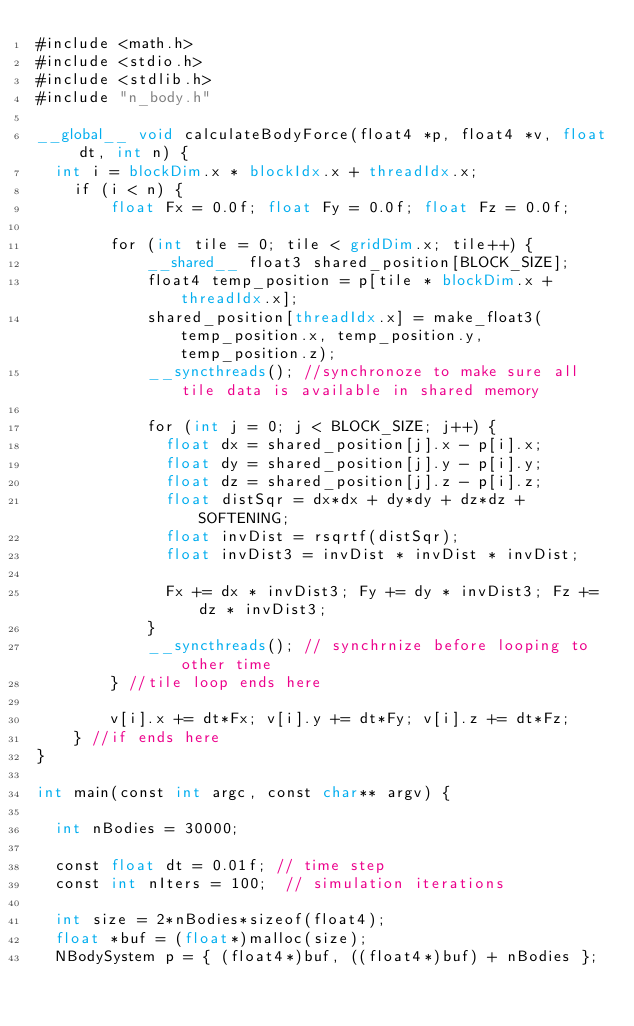Convert code to text. <code><loc_0><loc_0><loc_500><loc_500><_Cuda_>#include <math.h>
#include <stdio.h>
#include <stdlib.h>
#include "n_body.h"

__global__ void calculateBodyForce(float4 *p, float4 *v, float dt, int n) {
	int i = blockDim.x * blockIdx.x + threadIdx.x;
  	if (i < n) {
    		float Fx = 0.0f; float Fy = 0.0f; float Fz = 0.0f;

    		for (int tile = 0; tile < gridDim.x; tile++) {
      			__shared__ float3 shared_position[BLOCK_SIZE];
      			float4 temp_position = p[tile * blockDim.x + threadIdx.x];
      			shared_position[threadIdx.x] = make_float3(temp_position.x, temp_position.y, temp_position.z);
      			__syncthreads(); //synchronoze to make sure all tile data is available in shared memory

      			for (int j = 0; j < BLOCK_SIZE; j++) {
        			float dx = shared_position[j].x - p[i].x;
        			float dy = shared_position[j].y - p[i].y;
        			float dz = shared_position[j].z - p[i].z;
        			float distSqr = dx*dx + dy*dy + dz*dz + SOFTENING;
        			float invDist = rsqrtf(distSqr);
        			float invDist3 = invDist * invDist * invDist;

        			Fx += dx * invDist3; Fy += dy * invDist3; Fz += dz * invDist3;
      			}
      			__syncthreads(); // synchrnize before looping to other time
    		} //tile loop ends here		

    		v[i].x += dt*Fx; v[i].y += dt*Fy; v[i].z += dt*Fz;
  	} //if ends here
}

int main(const int argc, const char** argv) {
  
  int nBodies = 30000;
  
  const float dt = 0.01f; // time step
  const int nIters = 100;  // simulation iterations
  
  int size = 2*nBodies*sizeof(float4);
  float *buf = (float*)malloc(size);
  NBodySystem p = { (float4*)buf, ((float4*)buf) + nBodies };
</code> 